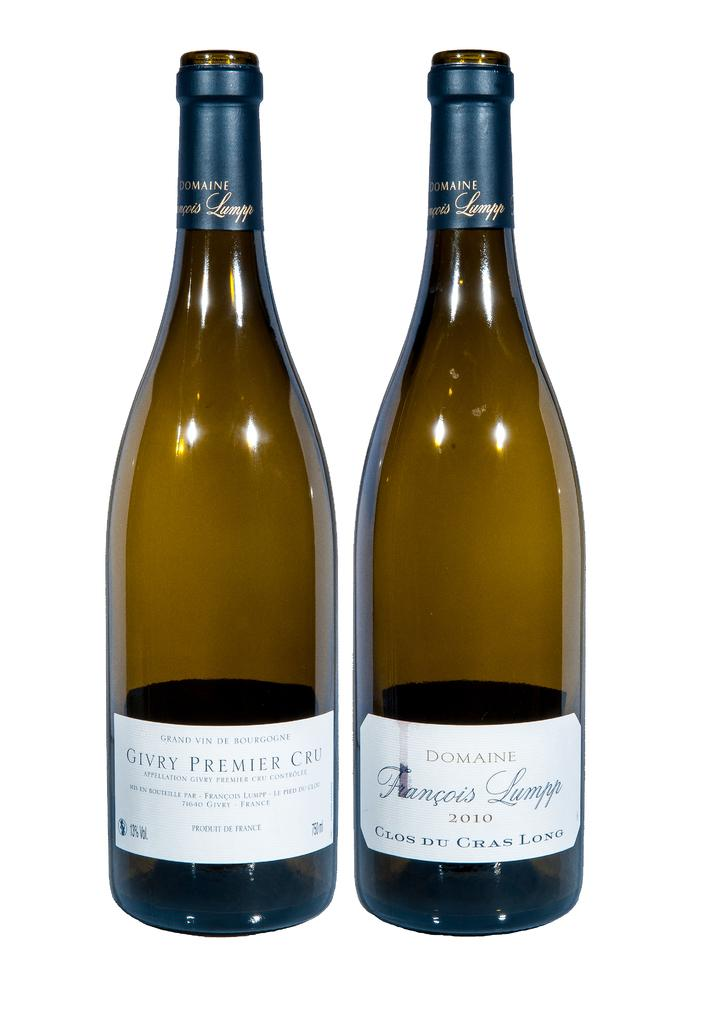<image>
Offer a succinct explanation of the picture presented. A bottle states it was produced i France while the right bottle has the year 2010. 